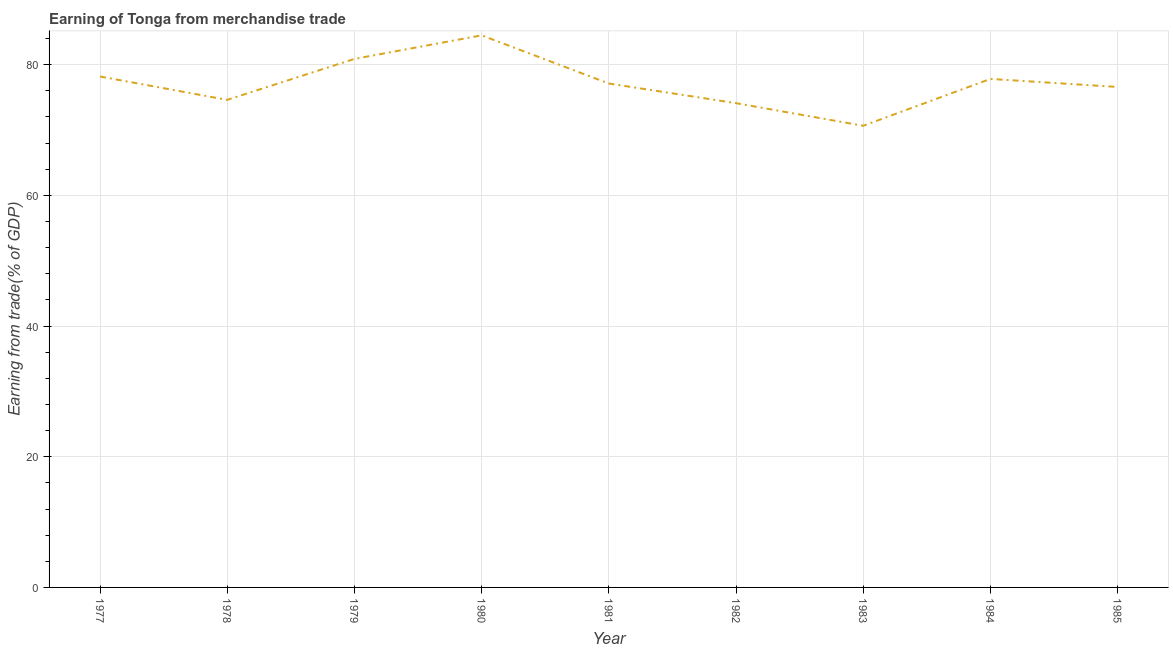What is the earning from merchandise trade in 1982?
Offer a very short reply. 74.11. Across all years, what is the maximum earning from merchandise trade?
Your answer should be compact. 84.49. Across all years, what is the minimum earning from merchandise trade?
Make the answer very short. 70.65. In which year was the earning from merchandise trade maximum?
Make the answer very short. 1980. In which year was the earning from merchandise trade minimum?
Your answer should be very brief. 1983. What is the sum of the earning from merchandise trade?
Make the answer very short. 694.47. What is the difference between the earning from merchandise trade in 1979 and 1983?
Your answer should be very brief. 10.23. What is the average earning from merchandise trade per year?
Provide a short and direct response. 77.16. What is the median earning from merchandise trade?
Make the answer very short. 77.12. What is the ratio of the earning from merchandise trade in 1979 to that in 1980?
Keep it short and to the point. 0.96. Is the earning from merchandise trade in 1977 less than that in 1979?
Your response must be concise. Yes. Is the difference between the earning from merchandise trade in 1979 and 1984 greater than the difference between any two years?
Your answer should be compact. No. What is the difference between the highest and the second highest earning from merchandise trade?
Offer a very short reply. 3.61. What is the difference between the highest and the lowest earning from merchandise trade?
Your answer should be compact. 13.84. How many lines are there?
Provide a succinct answer. 1. What is the difference between two consecutive major ticks on the Y-axis?
Your answer should be compact. 20. Does the graph contain any zero values?
Offer a terse response. No. What is the title of the graph?
Give a very brief answer. Earning of Tonga from merchandise trade. What is the label or title of the Y-axis?
Provide a short and direct response. Earning from trade(% of GDP). What is the Earning from trade(% of GDP) of 1977?
Offer a very short reply. 78.19. What is the Earning from trade(% of GDP) in 1978?
Make the answer very short. 74.62. What is the Earning from trade(% of GDP) in 1979?
Provide a succinct answer. 80.88. What is the Earning from trade(% of GDP) in 1980?
Provide a short and direct response. 84.49. What is the Earning from trade(% of GDP) in 1981?
Ensure brevity in your answer.  77.12. What is the Earning from trade(% of GDP) of 1982?
Your response must be concise. 74.11. What is the Earning from trade(% of GDP) of 1983?
Ensure brevity in your answer.  70.65. What is the Earning from trade(% of GDP) of 1984?
Ensure brevity in your answer.  77.82. What is the Earning from trade(% of GDP) of 1985?
Keep it short and to the point. 76.59. What is the difference between the Earning from trade(% of GDP) in 1977 and 1978?
Provide a short and direct response. 3.57. What is the difference between the Earning from trade(% of GDP) in 1977 and 1979?
Offer a very short reply. -2.69. What is the difference between the Earning from trade(% of GDP) in 1977 and 1980?
Your answer should be compact. -6.3. What is the difference between the Earning from trade(% of GDP) in 1977 and 1981?
Your answer should be compact. 1.07. What is the difference between the Earning from trade(% of GDP) in 1977 and 1982?
Your answer should be very brief. 4.08. What is the difference between the Earning from trade(% of GDP) in 1977 and 1983?
Provide a succinct answer. 7.54. What is the difference between the Earning from trade(% of GDP) in 1977 and 1984?
Provide a succinct answer. 0.37. What is the difference between the Earning from trade(% of GDP) in 1977 and 1985?
Provide a short and direct response. 1.6. What is the difference between the Earning from trade(% of GDP) in 1978 and 1979?
Offer a terse response. -6.27. What is the difference between the Earning from trade(% of GDP) in 1978 and 1980?
Your answer should be very brief. -9.88. What is the difference between the Earning from trade(% of GDP) in 1978 and 1981?
Offer a terse response. -2.5. What is the difference between the Earning from trade(% of GDP) in 1978 and 1982?
Offer a terse response. 0.5. What is the difference between the Earning from trade(% of GDP) in 1978 and 1983?
Provide a succinct answer. 3.97. What is the difference between the Earning from trade(% of GDP) in 1978 and 1984?
Provide a succinct answer. -3.21. What is the difference between the Earning from trade(% of GDP) in 1978 and 1985?
Your answer should be very brief. -1.98. What is the difference between the Earning from trade(% of GDP) in 1979 and 1980?
Provide a succinct answer. -3.61. What is the difference between the Earning from trade(% of GDP) in 1979 and 1981?
Provide a short and direct response. 3.77. What is the difference between the Earning from trade(% of GDP) in 1979 and 1982?
Ensure brevity in your answer.  6.77. What is the difference between the Earning from trade(% of GDP) in 1979 and 1983?
Provide a short and direct response. 10.23. What is the difference between the Earning from trade(% of GDP) in 1979 and 1984?
Offer a terse response. 3.06. What is the difference between the Earning from trade(% of GDP) in 1979 and 1985?
Your response must be concise. 4.29. What is the difference between the Earning from trade(% of GDP) in 1980 and 1981?
Offer a very short reply. 7.37. What is the difference between the Earning from trade(% of GDP) in 1980 and 1982?
Make the answer very short. 10.38. What is the difference between the Earning from trade(% of GDP) in 1980 and 1983?
Offer a terse response. 13.84. What is the difference between the Earning from trade(% of GDP) in 1980 and 1984?
Offer a very short reply. 6.67. What is the difference between the Earning from trade(% of GDP) in 1980 and 1985?
Provide a short and direct response. 7.9. What is the difference between the Earning from trade(% of GDP) in 1981 and 1982?
Your response must be concise. 3.01. What is the difference between the Earning from trade(% of GDP) in 1981 and 1983?
Your answer should be compact. 6.47. What is the difference between the Earning from trade(% of GDP) in 1981 and 1984?
Give a very brief answer. -0.7. What is the difference between the Earning from trade(% of GDP) in 1981 and 1985?
Your answer should be very brief. 0.53. What is the difference between the Earning from trade(% of GDP) in 1982 and 1983?
Your answer should be compact. 3.46. What is the difference between the Earning from trade(% of GDP) in 1982 and 1984?
Your answer should be very brief. -3.71. What is the difference between the Earning from trade(% of GDP) in 1982 and 1985?
Make the answer very short. -2.48. What is the difference between the Earning from trade(% of GDP) in 1983 and 1984?
Ensure brevity in your answer.  -7.17. What is the difference between the Earning from trade(% of GDP) in 1983 and 1985?
Your response must be concise. -5.94. What is the difference between the Earning from trade(% of GDP) in 1984 and 1985?
Give a very brief answer. 1.23. What is the ratio of the Earning from trade(% of GDP) in 1977 to that in 1978?
Your response must be concise. 1.05. What is the ratio of the Earning from trade(% of GDP) in 1977 to that in 1979?
Offer a terse response. 0.97. What is the ratio of the Earning from trade(% of GDP) in 1977 to that in 1980?
Give a very brief answer. 0.93. What is the ratio of the Earning from trade(% of GDP) in 1977 to that in 1981?
Provide a short and direct response. 1.01. What is the ratio of the Earning from trade(% of GDP) in 1977 to that in 1982?
Your answer should be compact. 1.05. What is the ratio of the Earning from trade(% of GDP) in 1977 to that in 1983?
Ensure brevity in your answer.  1.11. What is the ratio of the Earning from trade(% of GDP) in 1978 to that in 1979?
Provide a short and direct response. 0.92. What is the ratio of the Earning from trade(% of GDP) in 1978 to that in 1980?
Give a very brief answer. 0.88. What is the ratio of the Earning from trade(% of GDP) in 1978 to that in 1981?
Ensure brevity in your answer.  0.97. What is the ratio of the Earning from trade(% of GDP) in 1978 to that in 1982?
Keep it short and to the point. 1.01. What is the ratio of the Earning from trade(% of GDP) in 1978 to that in 1983?
Keep it short and to the point. 1.06. What is the ratio of the Earning from trade(% of GDP) in 1978 to that in 1984?
Your answer should be very brief. 0.96. What is the ratio of the Earning from trade(% of GDP) in 1978 to that in 1985?
Keep it short and to the point. 0.97. What is the ratio of the Earning from trade(% of GDP) in 1979 to that in 1980?
Give a very brief answer. 0.96. What is the ratio of the Earning from trade(% of GDP) in 1979 to that in 1981?
Offer a very short reply. 1.05. What is the ratio of the Earning from trade(% of GDP) in 1979 to that in 1982?
Your answer should be very brief. 1.09. What is the ratio of the Earning from trade(% of GDP) in 1979 to that in 1983?
Your response must be concise. 1.15. What is the ratio of the Earning from trade(% of GDP) in 1979 to that in 1984?
Make the answer very short. 1.04. What is the ratio of the Earning from trade(% of GDP) in 1979 to that in 1985?
Provide a short and direct response. 1.06. What is the ratio of the Earning from trade(% of GDP) in 1980 to that in 1981?
Keep it short and to the point. 1.1. What is the ratio of the Earning from trade(% of GDP) in 1980 to that in 1982?
Ensure brevity in your answer.  1.14. What is the ratio of the Earning from trade(% of GDP) in 1980 to that in 1983?
Offer a very short reply. 1.2. What is the ratio of the Earning from trade(% of GDP) in 1980 to that in 1984?
Offer a very short reply. 1.09. What is the ratio of the Earning from trade(% of GDP) in 1980 to that in 1985?
Your answer should be very brief. 1.1. What is the ratio of the Earning from trade(% of GDP) in 1981 to that in 1982?
Provide a short and direct response. 1.04. What is the ratio of the Earning from trade(% of GDP) in 1981 to that in 1983?
Provide a succinct answer. 1.09. What is the ratio of the Earning from trade(% of GDP) in 1981 to that in 1984?
Provide a short and direct response. 0.99. What is the ratio of the Earning from trade(% of GDP) in 1982 to that in 1983?
Keep it short and to the point. 1.05. What is the ratio of the Earning from trade(% of GDP) in 1982 to that in 1984?
Provide a short and direct response. 0.95. What is the ratio of the Earning from trade(% of GDP) in 1983 to that in 1984?
Provide a short and direct response. 0.91. What is the ratio of the Earning from trade(% of GDP) in 1983 to that in 1985?
Provide a short and direct response. 0.92. What is the ratio of the Earning from trade(% of GDP) in 1984 to that in 1985?
Provide a succinct answer. 1.02. 